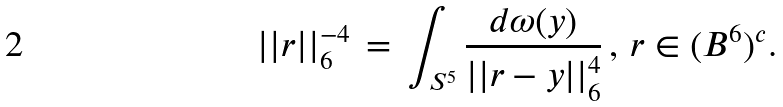Convert formula to latex. <formula><loc_0><loc_0><loc_500><loc_500>| | r | | _ { 6 } ^ { - 4 } \, = \, \int _ { S ^ { 5 } } \frac { d \omega ( y ) } { | | r - y | | _ { 6 } ^ { 4 } } \, , \, r \in ( B ^ { 6 } ) ^ { c } .</formula> 